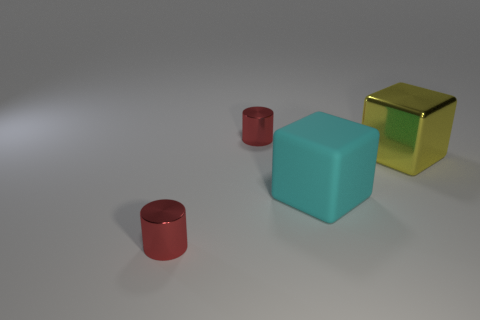Add 3 metal objects. How many objects exist? 7 Add 4 cylinders. How many cylinders are left? 6 Add 4 cyan things. How many cyan things exist? 5 Subtract 1 red cylinders. How many objects are left? 3 Subtract all large yellow blocks. Subtract all tiny cylinders. How many objects are left? 1 